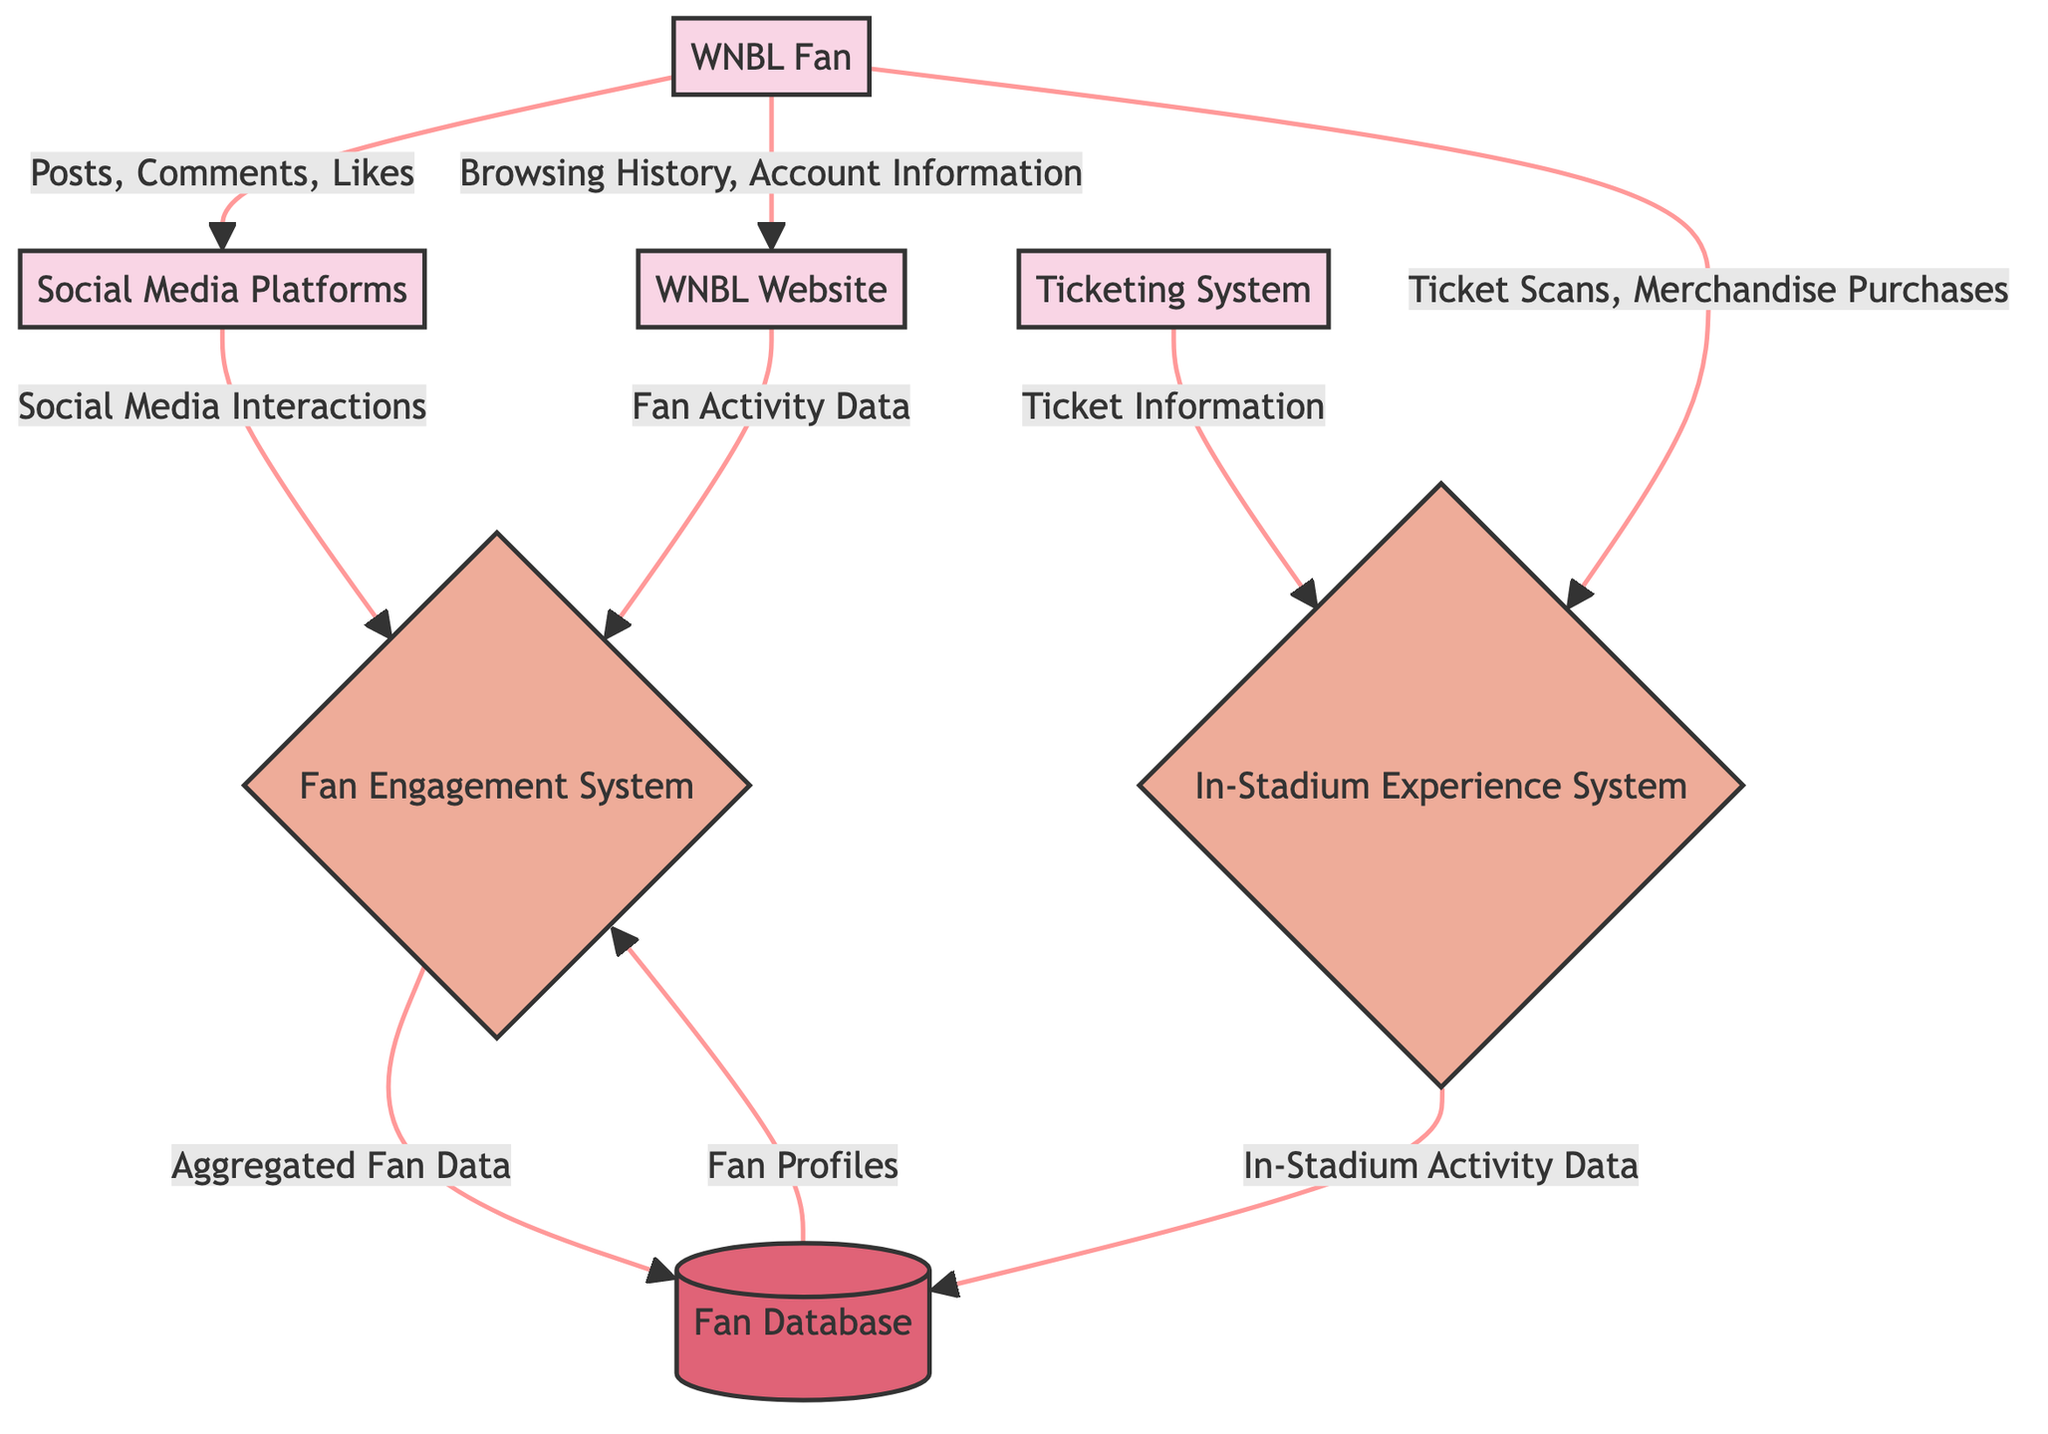What is the total number of external entities in the diagram? The diagram shows four external entities: WNBL Fan, Social Media Platforms, WNBL Website, and Ticketing System. Counting these gives a total of 4 external entities.
Answer: 4 What data flows from the WNBL Fan to the Social Media Platforms? The arrow from WNBL Fan to Social Media Platforms indicates that the data flowing is "Posts, Comments, Likes". This specifies the type of interaction WNBL Fans have on social media.
Answer: Posts, Comments, Likes Which process receives "Fan Activity Data"? The arrow from the WNBL Website to the Fan Engagement System indicates that "Fan Activity Data" is the particular data flowing into the Fan Engagement System. This establishes a direct relationship between these two components.
Answer: Fan Engagement System From which external entity does the In-Stadium Experience System receive ticket information? The flow from the Ticketing System to the In-Stadium Experience System signifies that "Ticket Information" comes from the Ticketing System, establishing that this external entity is essential for the In-Stadium Experience.
Answer: Ticketing System What type of data is stored in the Fan Database? The Fan Database receives two types of data: "Aggregated Fan Data" from the Fan Engagement System and "In-Stadium Activity Data" from the In-Stadium Experience System. Therefore, the Fan Database acts as a storage for these aggregated data types.
Answer: Aggregated Fan Data, In-Stadium Activity Data What is the total number of data flows in the diagram? The diagram outlines a total of 9 data flows, which include all the directed arrows that represent the information movement between entities and processes. Counting each one carefully yields 9.
Answer: 9 Which entity sends data to the Fan Engagement System? The Fan Engagement System receives data from two specific sources: the Social Media Platforms, providing "Social Media Interactions", and the WNBL Website, offering "Fan Activity Data". This highlights its function in aggregating diverse data sources.
Answer: Social Media Platforms, WNBL Website How does the In-Stadium Experience System contribute to the Fan Database? The flow from the In-Stadium Experience System to the Fan Database indicates that it contributes "In-Stadium Activity Data", which helps in enhancing information storage about fan engagement during matches.
Answer: In-Stadium Activity Data 